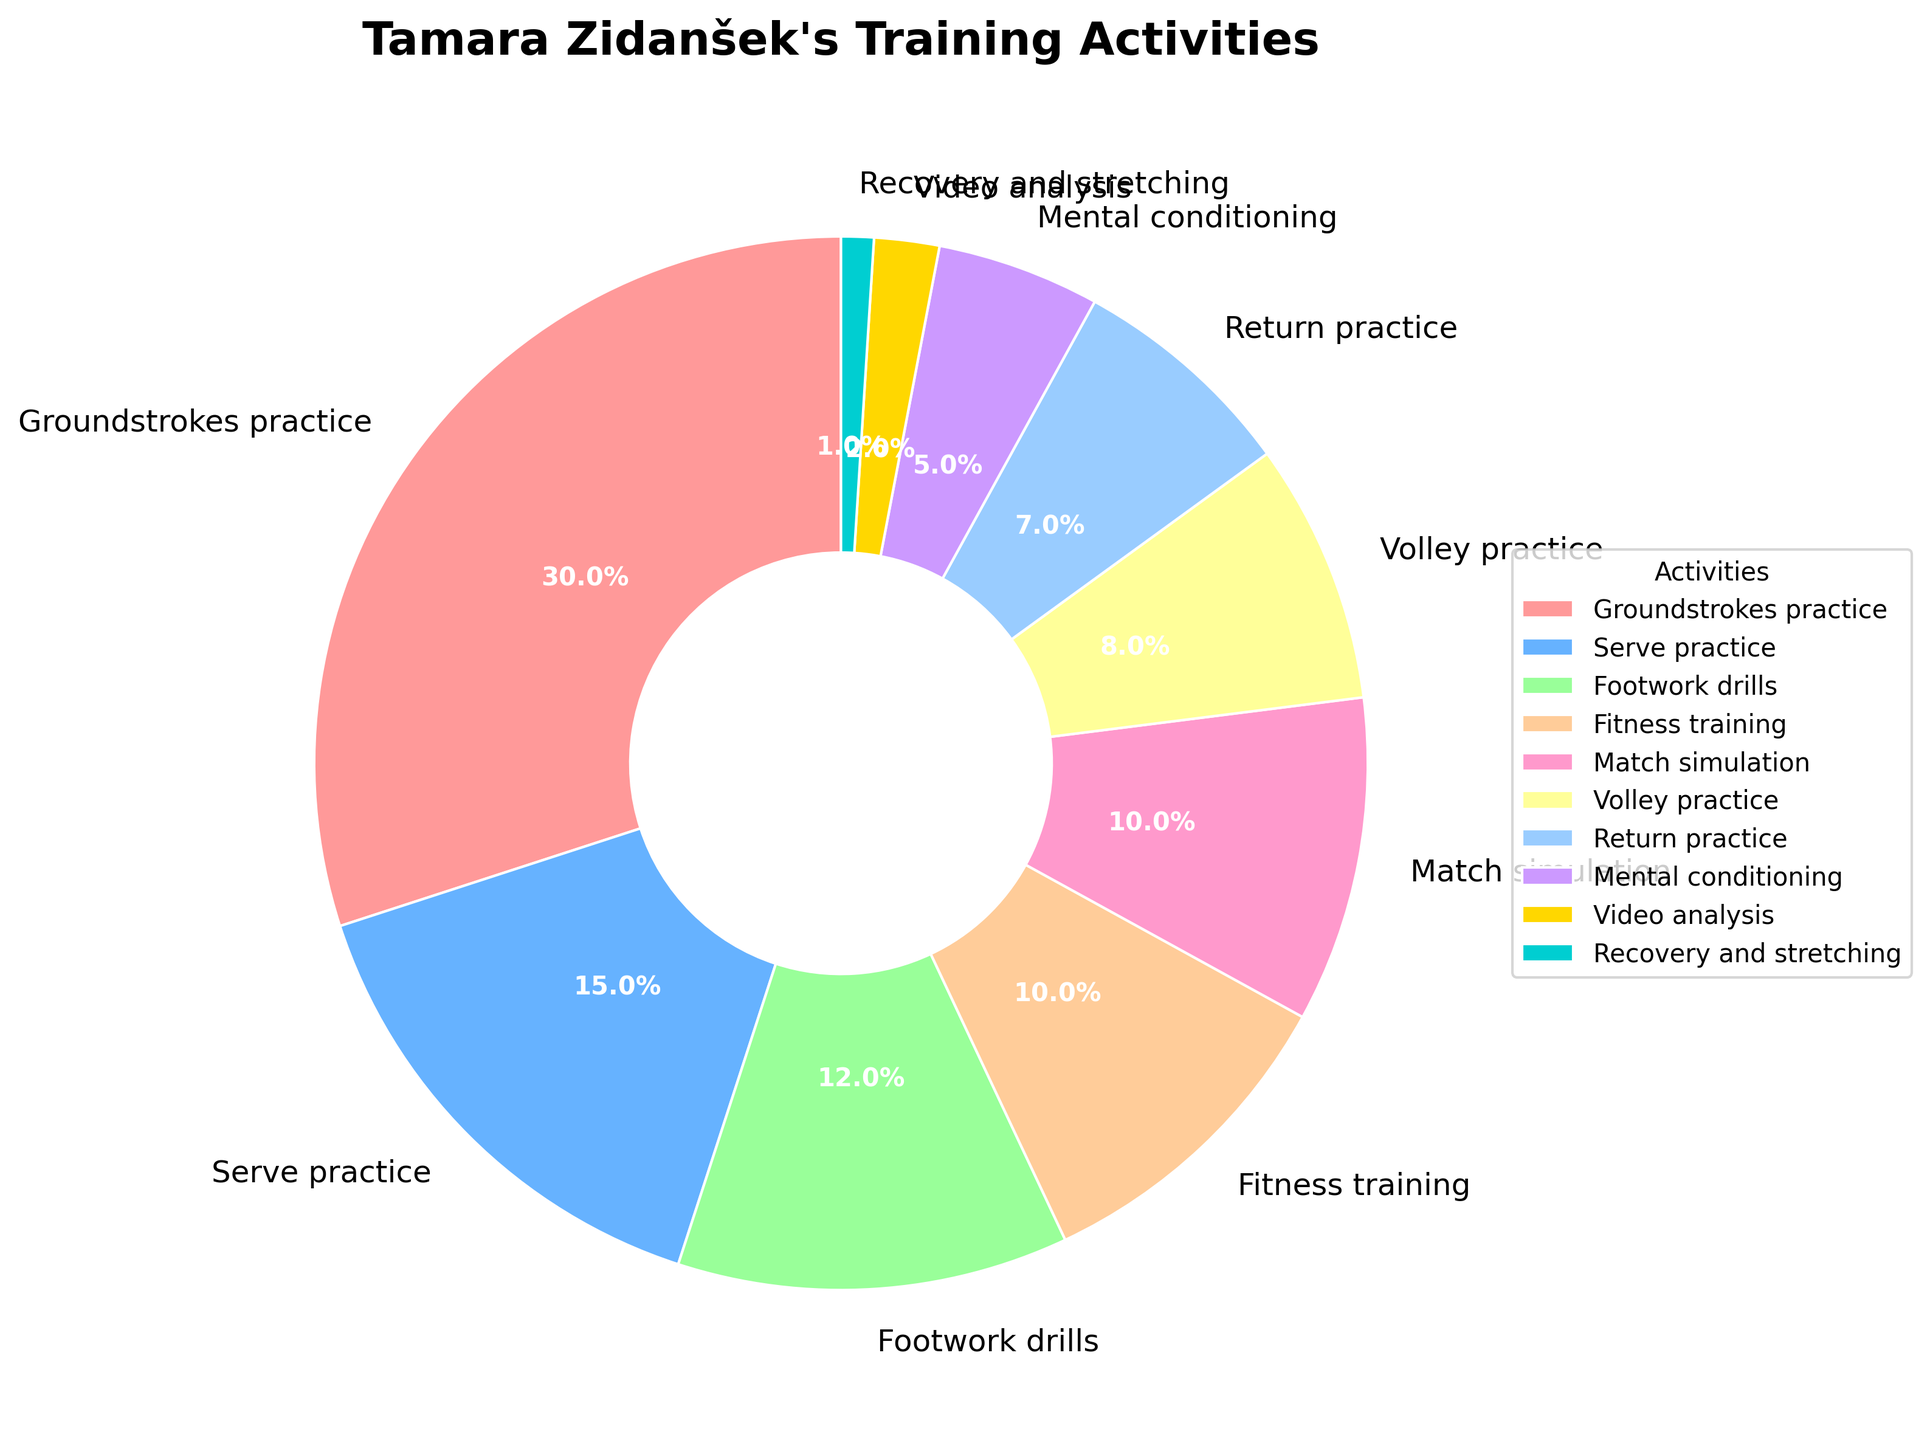Which activity takes up the largest percentage of Tamara Zidanšek's training session? By looking at the pie chart, we can see the activity with the largest percentage. In this case, 'Groundstrokes practice' covers the largest portion.
Answer: Groundstrokes practice How much more time does Tamara spend on serve practice compared to return practice? Serve practice takes up 15% of the time while return practice takes 7%. To find the difference, subtract the smaller percentage from the larger one: 15% - 7% = 8%.
Answer: 8% What is the combined percentage of time spent on match simulation and volley practice? Match simulation takes up 10% and volley practice takes up 8%. Adding these percentages together gives: 10% + 8% = 18%.
Answer: 18% Which activity is given the least amount of time in Tamara's training session? The smallest slice of the pie represents the activity with the least percentage, which is 'Recovery and stretching' at 1%.
Answer: Recovery and stretching Does Tamara spend more time on footwork drills than on fitness training? By how much? Footwork drills take up 12% of the time, while fitness training takes up 10%. The difference is: 12% - 10% = 2%.
Answer: Yes, 2% What is the average percentage of time spent on serve practice, fitness training, and mental conditioning? Adding the percentages for serve practice (15%), fitness training (10%), and mental conditioning (5%) gives: 15% + 10% + 5% = 30%. Dividing by the number of activities (3) gives the average: 30% / 3 = 10%.
Answer: 10% Which two activities combined take up the same amount of time as groundstrokes practice? Groundstrokes practice accounts for 30% of the time. Matching pairs whose sum is 30% are 'Serve practice' (15%) and 'Footwork drills' (12%) plus 'Recovery and stretching' (1%) which together total: 15% + 12% + 1% = 30%.
Answer: Serve practice and Footwork drills plus Recovery and stretching What percentage of Tamara's training time is spent on activities other than match simulation? Subtract the percentage of match simulation from 100%: 100% - 10% = 90%.
Answer: 90% Comparing mental conditioning and video analysis, which activity is given more attention, and by what percentage difference? Mental conditioning takes up 5% of the time while video analysis takes up 2%. The difference is: 5% - 2% = 3%.
Answer: Mental conditioning, 3% Which activity segment is colored in blue on the pie chart? By observing the pie chart's color scheme, we can identify which activity corresponds to the blue-colored segment. Based on the data, 'Serve practice' is colored in blue.
Answer: Serve practice 